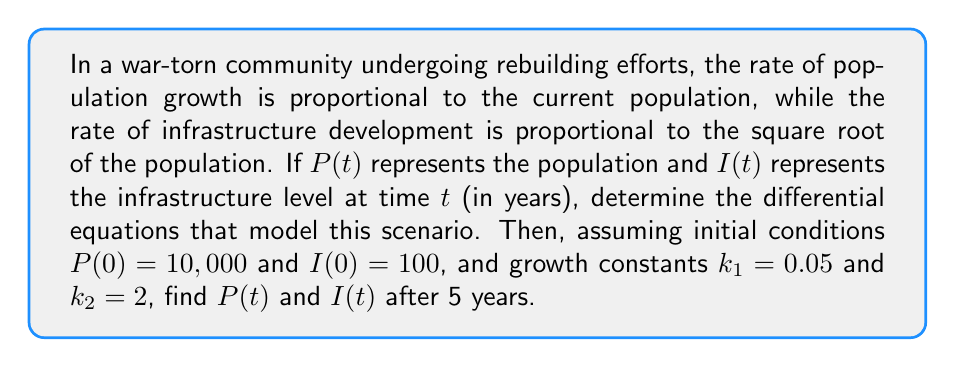Could you help me with this problem? 1. Model the population growth:
   The rate of change of population is proportional to the current population.
   $$\frac{dP}{dt} = k_1P$$
   where $k_1$ is the population growth constant.

2. Model the infrastructure development:
   The rate of change of infrastructure is proportional to the square root of the population.
   $$\frac{dI}{dt} = k_2\sqrt{P}$$
   where $k_2$ is the infrastructure development constant.

3. Solve the population equation:
   $$\frac{dP}{dt} = k_1P$$
   $$\int \frac{dP}{P} = \int k_1 dt$$
   $$\ln P = k_1t + C$$
   $$P(t) = Ce^{k_1t}$$
   Using the initial condition $P(0) = 10,000$:
   $$10,000 = Ce^{0}$$
   $$C = 10,000$$
   Therefore, $$P(t) = 10,000e^{0.05t}$$

4. Solve the infrastructure equation:
   $$\frac{dI}{dt} = k_2\sqrt{P} = k_2\sqrt{10,000e^{0.05t}}$$
   $$\frac{dI}{dt} = k_2\sqrt{10,000}e^{0.025t} = 100k_2e^{0.025t}$$
   $$\int dI = \int 100k_2e^{0.025t} dt$$
   $$I(t) = 4000k_2e^{0.025t} + C$$
   Using the initial condition $I(0) = 100$:
   $$100 = 4000k_2 + C$$
   $$C = 100 - 4000k_2$$
   Therefore, $$I(t) = 4000k_2(e^{0.025t} - 1) + 100$$

5. Calculate $P(5)$ and $I(5)$:
   $$P(5) = 10,000e^{0.05 \cdot 5} \approx 12,840$$
   $$I(5) = 4000 \cdot 2(e^{0.025 \cdot 5} - 1) + 100 \approx 1,036$$
Answer: $P(5) \approx 12,840$, $I(5) \approx 1,036$ 